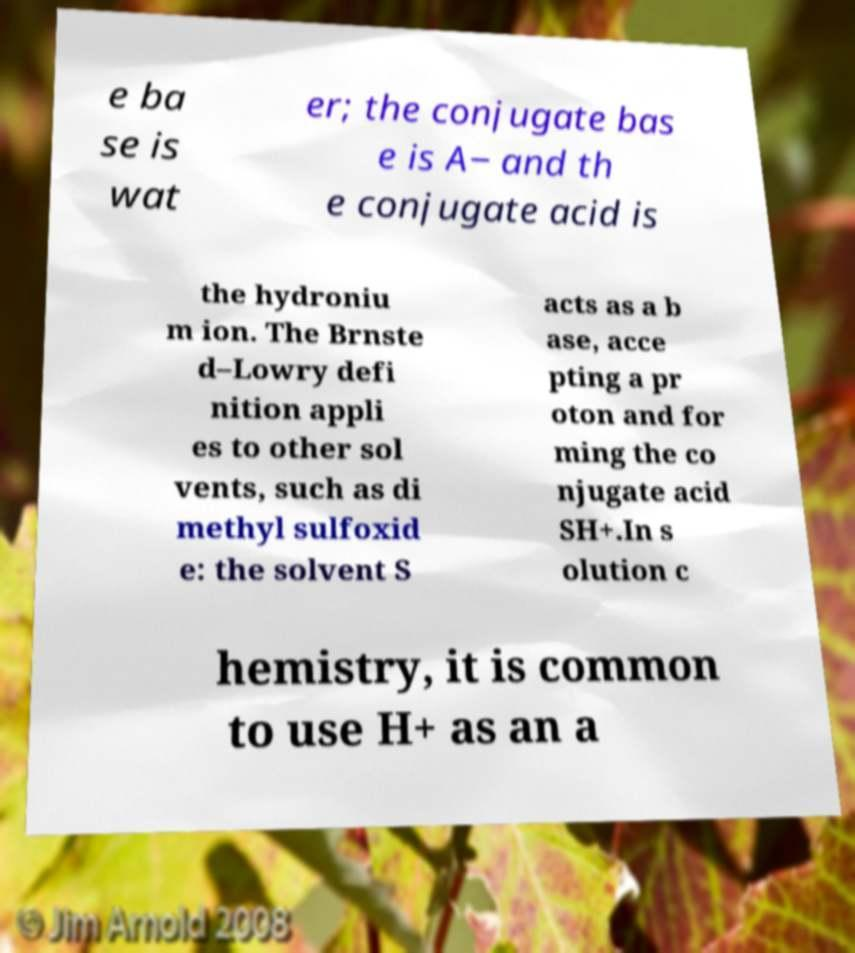What messages or text are displayed in this image? I need them in a readable, typed format. e ba se is wat er; the conjugate bas e is A− and th e conjugate acid is the hydroniu m ion. The Brnste d–Lowry defi nition appli es to other sol vents, such as di methyl sulfoxid e: the solvent S acts as a b ase, acce pting a pr oton and for ming the co njugate acid SH+.In s olution c hemistry, it is common to use H+ as an a 